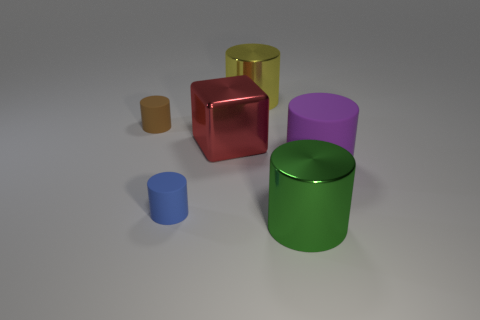Subtract all big matte cylinders. How many cylinders are left? 4 Subtract all blue cylinders. How many cylinders are left? 4 Subtract all blue cylinders. Subtract all red balls. How many cylinders are left? 4 Add 4 blue matte cylinders. How many objects exist? 10 Subtract all cylinders. How many objects are left? 1 Subtract 1 green cylinders. How many objects are left? 5 Subtract all green cylinders. Subtract all purple objects. How many objects are left? 4 Add 2 small things. How many small things are left? 4 Add 3 blocks. How many blocks exist? 4 